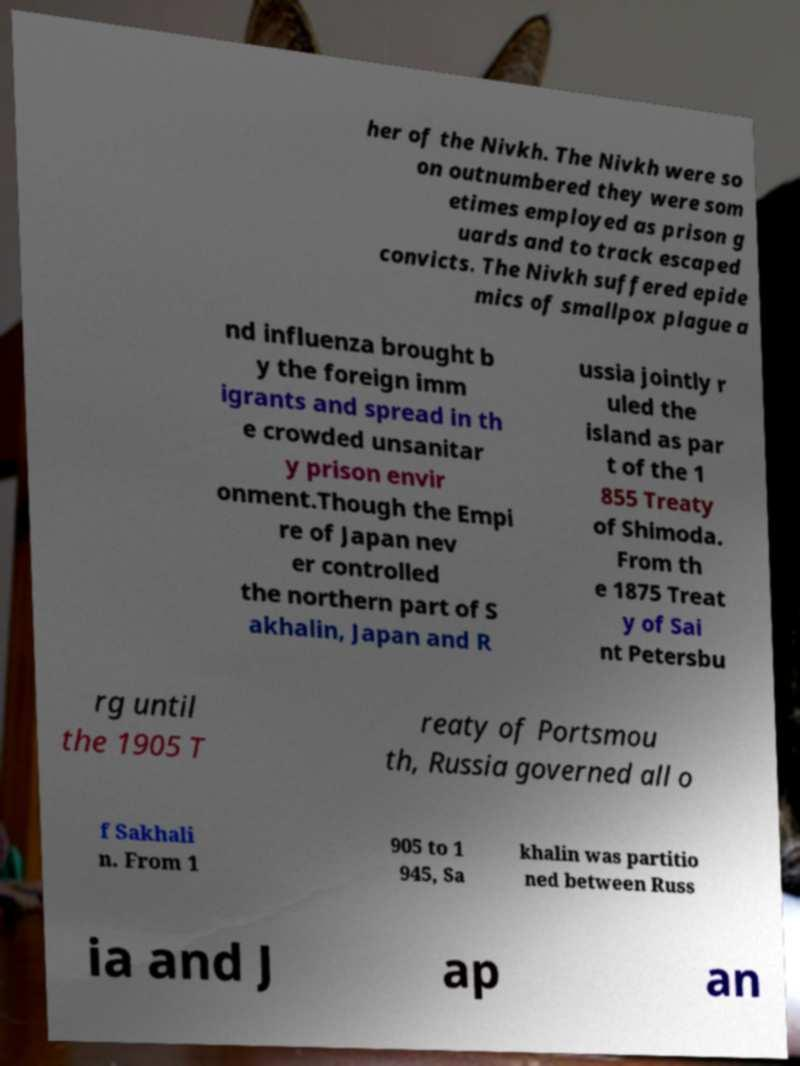Please identify and transcribe the text found in this image. her of the Nivkh. The Nivkh were so on outnumbered they were som etimes employed as prison g uards and to track escaped convicts. The Nivkh suffered epide mics of smallpox plague a nd influenza brought b y the foreign imm igrants and spread in th e crowded unsanitar y prison envir onment.Though the Empi re of Japan nev er controlled the northern part of S akhalin, Japan and R ussia jointly r uled the island as par t of the 1 855 Treaty of Shimoda. From th e 1875 Treat y of Sai nt Petersbu rg until the 1905 T reaty of Portsmou th, Russia governed all o f Sakhali n. From 1 905 to 1 945, Sa khalin was partitio ned between Russ ia and J ap an 